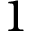<formula> <loc_0><loc_0><loc_500><loc_500>1</formula> 